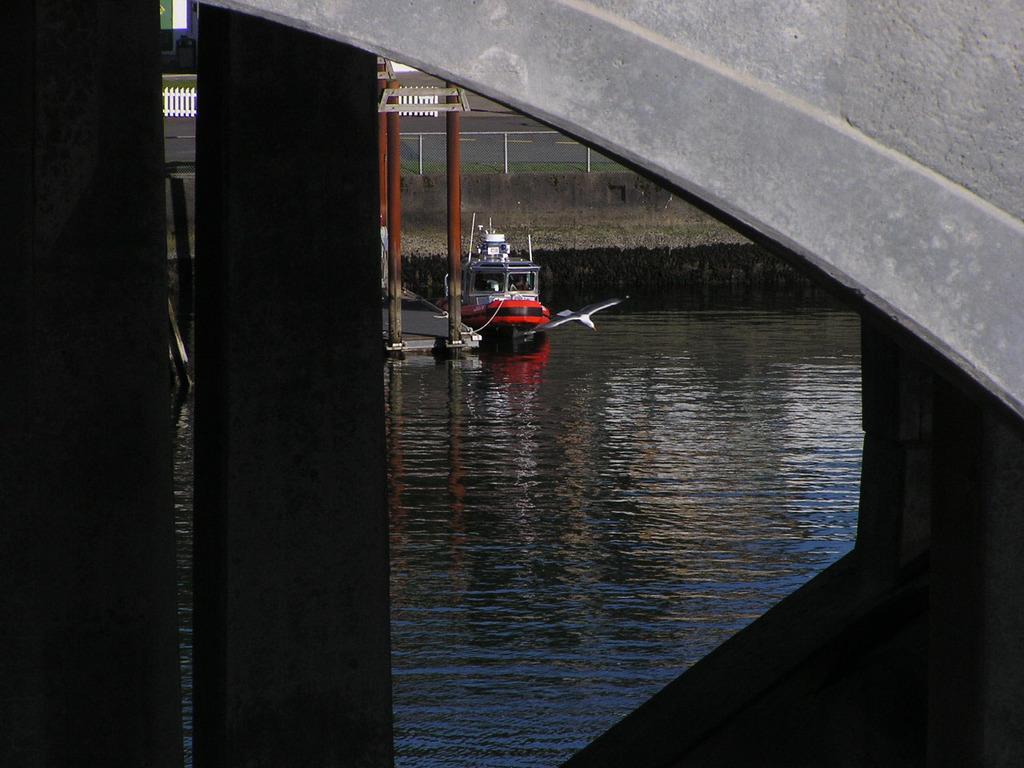Can you describe this image briefly? In this picture there is a red boat on the water. In front of the boat there is a bird which is flying. In the background I can see the trees, plants, grass, open area and poles. In the top right corner I can see the bridge wall. 